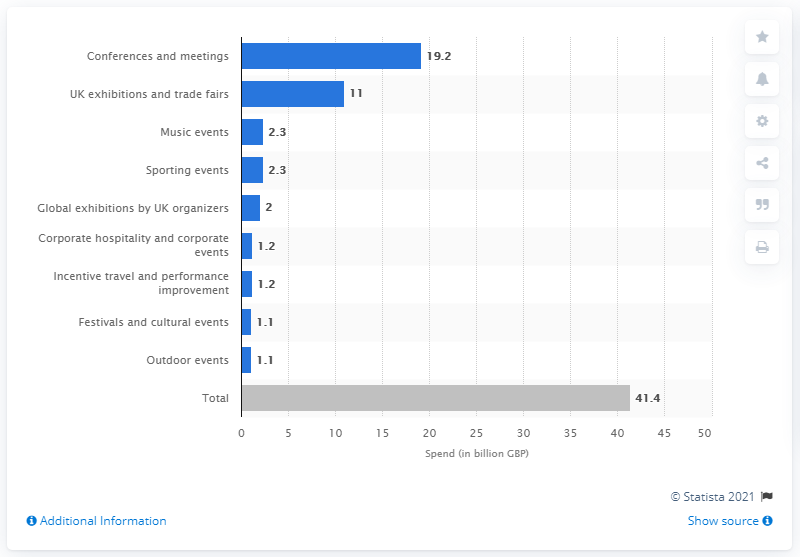Outline some significant characteristics in this image. The events sector is valued at 41.4 billion pounds. In 2017, the amount of British pounds spent on conferences and meetings was 19.2 billion pounds. 